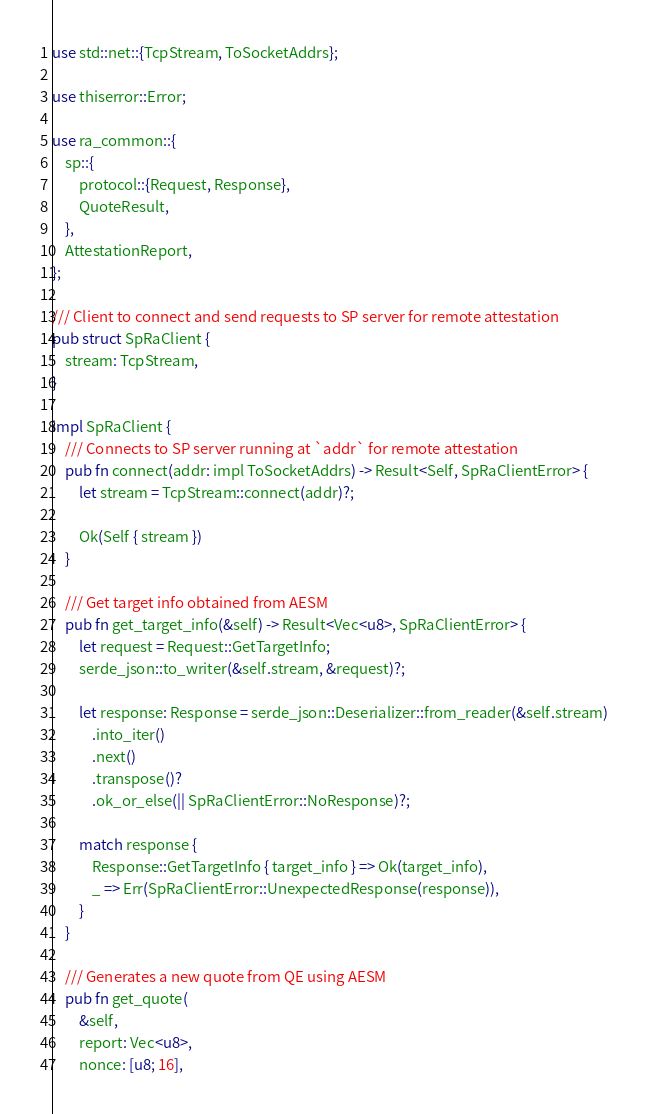<code> <loc_0><loc_0><loc_500><loc_500><_Rust_>use std::net::{TcpStream, ToSocketAddrs};

use thiserror::Error;

use ra_common::{
    sp::{
        protocol::{Request, Response},
        QuoteResult,
    },
    AttestationReport,
};

/// Client to connect and send requests to SP server for remote attestation
pub struct SpRaClient {
    stream: TcpStream,
}

impl SpRaClient {
    /// Connects to SP server running at `addr` for remote attestation
    pub fn connect(addr: impl ToSocketAddrs) -> Result<Self, SpRaClientError> {
        let stream = TcpStream::connect(addr)?;

        Ok(Self { stream })
    }

    /// Get target info obtained from AESM
    pub fn get_target_info(&self) -> Result<Vec<u8>, SpRaClientError> {
        let request = Request::GetTargetInfo;
        serde_json::to_writer(&self.stream, &request)?;

        let response: Response = serde_json::Deserializer::from_reader(&self.stream)
            .into_iter()
            .next()
            .transpose()?
            .ok_or_else(|| SpRaClientError::NoResponse)?;

        match response {
            Response::GetTargetInfo { target_info } => Ok(target_info),
            _ => Err(SpRaClientError::UnexpectedResponse(response)),
        }
    }

    /// Generates a new quote from QE using AESM
    pub fn get_quote(
        &self,
        report: Vec<u8>,
        nonce: [u8; 16],</code> 